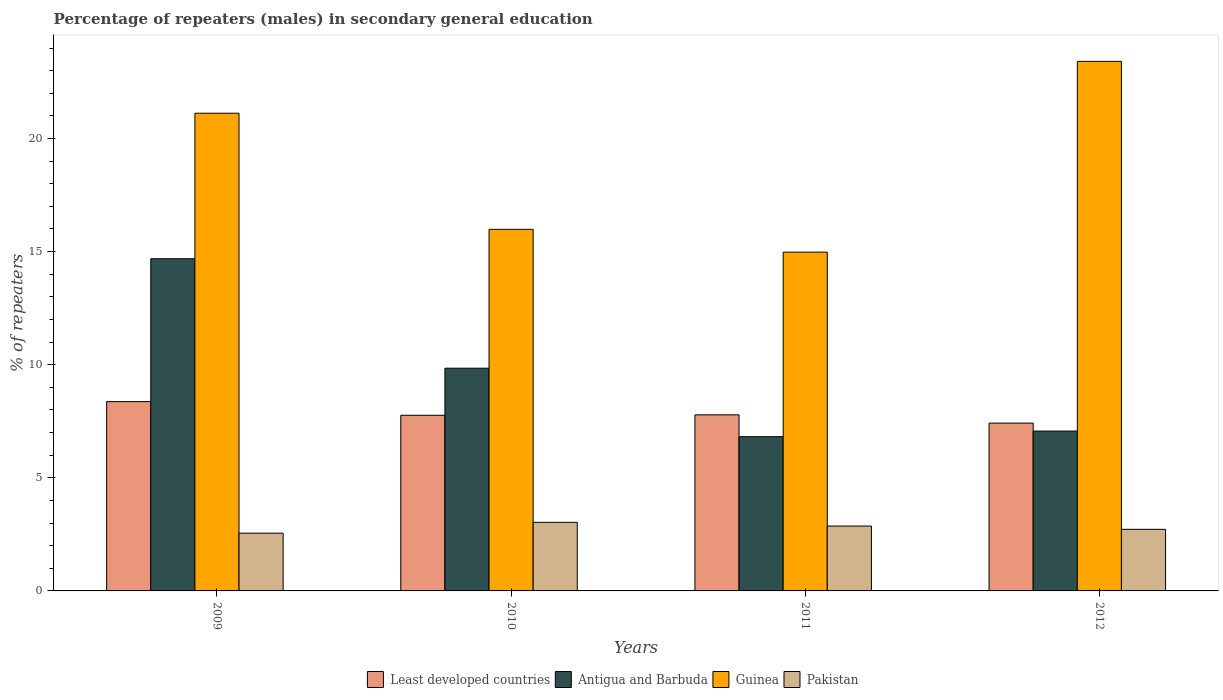How many different coloured bars are there?
Offer a terse response. 4. Are the number of bars on each tick of the X-axis equal?
Keep it short and to the point. Yes. How many bars are there on the 1st tick from the right?
Offer a terse response. 4. What is the label of the 4th group of bars from the left?
Ensure brevity in your answer.  2012. What is the percentage of male repeaters in Guinea in 2009?
Your answer should be compact. 21.12. Across all years, what is the maximum percentage of male repeaters in Guinea?
Give a very brief answer. 23.41. Across all years, what is the minimum percentage of male repeaters in Antigua and Barbuda?
Provide a succinct answer. 6.82. In which year was the percentage of male repeaters in Pakistan maximum?
Offer a very short reply. 2010. In which year was the percentage of male repeaters in Guinea minimum?
Ensure brevity in your answer.  2011. What is the total percentage of male repeaters in Pakistan in the graph?
Offer a terse response. 11.18. What is the difference between the percentage of male repeaters in Least developed countries in 2010 and that in 2011?
Ensure brevity in your answer.  -0.02. What is the difference between the percentage of male repeaters in Least developed countries in 2009 and the percentage of male repeaters in Antigua and Barbuda in 2012?
Offer a very short reply. 1.3. What is the average percentage of male repeaters in Guinea per year?
Your answer should be compact. 18.87. In the year 2009, what is the difference between the percentage of male repeaters in Guinea and percentage of male repeaters in Least developed countries?
Your answer should be compact. 12.75. In how many years, is the percentage of male repeaters in Least developed countries greater than 17 %?
Make the answer very short. 0. What is the ratio of the percentage of male repeaters in Pakistan in 2010 to that in 2011?
Keep it short and to the point. 1.06. Is the percentage of male repeaters in Antigua and Barbuda in 2010 less than that in 2012?
Provide a succinct answer. No. Is the difference between the percentage of male repeaters in Guinea in 2009 and 2011 greater than the difference between the percentage of male repeaters in Least developed countries in 2009 and 2011?
Provide a succinct answer. Yes. What is the difference between the highest and the second highest percentage of male repeaters in Guinea?
Ensure brevity in your answer.  2.29. What is the difference between the highest and the lowest percentage of male repeaters in Least developed countries?
Your answer should be compact. 0.95. Is the sum of the percentage of male repeaters in Guinea in 2010 and 2012 greater than the maximum percentage of male repeaters in Antigua and Barbuda across all years?
Provide a short and direct response. Yes. Is it the case that in every year, the sum of the percentage of male repeaters in Pakistan and percentage of male repeaters in Least developed countries is greater than the sum of percentage of male repeaters in Antigua and Barbuda and percentage of male repeaters in Guinea?
Offer a very short reply. No. What does the 1st bar from the left in 2010 represents?
Keep it short and to the point. Least developed countries. What does the 2nd bar from the right in 2011 represents?
Make the answer very short. Guinea. How many bars are there?
Provide a succinct answer. 16. Are all the bars in the graph horizontal?
Your answer should be compact. No. How many years are there in the graph?
Your answer should be compact. 4. Where does the legend appear in the graph?
Keep it short and to the point. Bottom center. How many legend labels are there?
Provide a succinct answer. 4. What is the title of the graph?
Your answer should be compact. Percentage of repeaters (males) in secondary general education. What is the label or title of the X-axis?
Offer a terse response. Years. What is the label or title of the Y-axis?
Give a very brief answer. % of repeaters. What is the % of repeaters of Least developed countries in 2009?
Your response must be concise. 8.37. What is the % of repeaters in Antigua and Barbuda in 2009?
Provide a short and direct response. 14.69. What is the % of repeaters of Guinea in 2009?
Provide a short and direct response. 21.12. What is the % of repeaters in Pakistan in 2009?
Offer a terse response. 2.55. What is the % of repeaters of Least developed countries in 2010?
Offer a very short reply. 7.76. What is the % of repeaters in Antigua and Barbuda in 2010?
Your answer should be very brief. 9.85. What is the % of repeaters of Guinea in 2010?
Provide a short and direct response. 15.98. What is the % of repeaters in Pakistan in 2010?
Provide a succinct answer. 3.03. What is the % of repeaters of Least developed countries in 2011?
Offer a very short reply. 7.78. What is the % of repeaters of Antigua and Barbuda in 2011?
Your response must be concise. 6.82. What is the % of repeaters in Guinea in 2011?
Provide a short and direct response. 14.98. What is the % of repeaters of Pakistan in 2011?
Provide a short and direct response. 2.87. What is the % of repeaters of Least developed countries in 2012?
Your answer should be very brief. 7.42. What is the % of repeaters in Antigua and Barbuda in 2012?
Offer a terse response. 7.07. What is the % of repeaters of Guinea in 2012?
Offer a terse response. 23.41. What is the % of repeaters of Pakistan in 2012?
Offer a terse response. 2.72. Across all years, what is the maximum % of repeaters in Least developed countries?
Your answer should be compact. 8.37. Across all years, what is the maximum % of repeaters in Antigua and Barbuda?
Make the answer very short. 14.69. Across all years, what is the maximum % of repeaters of Guinea?
Your answer should be very brief. 23.41. Across all years, what is the maximum % of repeaters in Pakistan?
Provide a short and direct response. 3.03. Across all years, what is the minimum % of repeaters of Least developed countries?
Give a very brief answer. 7.42. Across all years, what is the minimum % of repeaters of Antigua and Barbuda?
Keep it short and to the point. 6.82. Across all years, what is the minimum % of repeaters of Guinea?
Ensure brevity in your answer.  14.98. Across all years, what is the minimum % of repeaters in Pakistan?
Provide a short and direct response. 2.55. What is the total % of repeaters in Least developed countries in the graph?
Ensure brevity in your answer.  31.34. What is the total % of repeaters in Antigua and Barbuda in the graph?
Give a very brief answer. 38.42. What is the total % of repeaters in Guinea in the graph?
Provide a short and direct response. 75.49. What is the total % of repeaters of Pakistan in the graph?
Provide a short and direct response. 11.18. What is the difference between the % of repeaters in Least developed countries in 2009 and that in 2010?
Your answer should be very brief. 0.6. What is the difference between the % of repeaters in Antigua and Barbuda in 2009 and that in 2010?
Provide a short and direct response. 4.84. What is the difference between the % of repeaters in Guinea in 2009 and that in 2010?
Offer a very short reply. 5.13. What is the difference between the % of repeaters of Pakistan in 2009 and that in 2010?
Your answer should be very brief. -0.48. What is the difference between the % of repeaters in Least developed countries in 2009 and that in 2011?
Keep it short and to the point. 0.58. What is the difference between the % of repeaters of Antigua and Barbuda in 2009 and that in 2011?
Make the answer very short. 7.87. What is the difference between the % of repeaters of Guinea in 2009 and that in 2011?
Make the answer very short. 6.14. What is the difference between the % of repeaters in Pakistan in 2009 and that in 2011?
Your response must be concise. -0.31. What is the difference between the % of repeaters of Least developed countries in 2009 and that in 2012?
Provide a succinct answer. 0.95. What is the difference between the % of repeaters in Antigua and Barbuda in 2009 and that in 2012?
Give a very brief answer. 7.62. What is the difference between the % of repeaters in Guinea in 2009 and that in 2012?
Offer a terse response. -2.29. What is the difference between the % of repeaters in Pakistan in 2009 and that in 2012?
Give a very brief answer. -0.17. What is the difference between the % of repeaters in Least developed countries in 2010 and that in 2011?
Ensure brevity in your answer.  -0.02. What is the difference between the % of repeaters of Antigua and Barbuda in 2010 and that in 2011?
Your answer should be very brief. 3.03. What is the difference between the % of repeaters in Guinea in 2010 and that in 2011?
Provide a succinct answer. 1.01. What is the difference between the % of repeaters of Pakistan in 2010 and that in 2011?
Provide a succinct answer. 0.16. What is the difference between the % of repeaters in Least developed countries in 2010 and that in 2012?
Ensure brevity in your answer.  0.35. What is the difference between the % of repeaters in Antigua and Barbuda in 2010 and that in 2012?
Offer a terse response. 2.78. What is the difference between the % of repeaters in Guinea in 2010 and that in 2012?
Your answer should be compact. -7.43. What is the difference between the % of repeaters in Pakistan in 2010 and that in 2012?
Offer a terse response. 0.31. What is the difference between the % of repeaters in Least developed countries in 2011 and that in 2012?
Ensure brevity in your answer.  0.37. What is the difference between the % of repeaters of Antigua and Barbuda in 2011 and that in 2012?
Give a very brief answer. -0.25. What is the difference between the % of repeaters in Guinea in 2011 and that in 2012?
Your answer should be compact. -8.43. What is the difference between the % of repeaters of Pakistan in 2011 and that in 2012?
Give a very brief answer. 0.15. What is the difference between the % of repeaters of Least developed countries in 2009 and the % of repeaters of Antigua and Barbuda in 2010?
Keep it short and to the point. -1.48. What is the difference between the % of repeaters in Least developed countries in 2009 and the % of repeaters in Guinea in 2010?
Give a very brief answer. -7.62. What is the difference between the % of repeaters in Least developed countries in 2009 and the % of repeaters in Pakistan in 2010?
Provide a short and direct response. 5.34. What is the difference between the % of repeaters in Antigua and Barbuda in 2009 and the % of repeaters in Guinea in 2010?
Offer a terse response. -1.3. What is the difference between the % of repeaters in Antigua and Barbuda in 2009 and the % of repeaters in Pakistan in 2010?
Offer a terse response. 11.65. What is the difference between the % of repeaters of Guinea in 2009 and the % of repeaters of Pakistan in 2010?
Offer a very short reply. 18.09. What is the difference between the % of repeaters in Least developed countries in 2009 and the % of repeaters in Antigua and Barbuda in 2011?
Keep it short and to the point. 1.55. What is the difference between the % of repeaters in Least developed countries in 2009 and the % of repeaters in Guinea in 2011?
Provide a short and direct response. -6.61. What is the difference between the % of repeaters of Least developed countries in 2009 and the % of repeaters of Pakistan in 2011?
Your answer should be compact. 5.5. What is the difference between the % of repeaters in Antigua and Barbuda in 2009 and the % of repeaters in Guinea in 2011?
Ensure brevity in your answer.  -0.29. What is the difference between the % of repeaters of Antigua and Barbuda in 2009 and the % of repeaters of Pakistan in 2011?
Offer a very short reply. 11.82. What is the difference between the % of repeaters of Guinea in 2009 and the % of repeaters of Pakistan in 2011?
Offer a terse response. 18.25. What is the difference between the % of repeaters in Least developed countries in 2009 and the % of repeaters in Antigua and Barbuda in 2012?
Offer a terse response. 1.3. What is the difference between the % of repeaters in Least developed countries in 2009 and the % of repeaters in Guinea in 2012?
Give a very brief answer. -15.04. What is the difference between the % of repeaters in Least developed countries in 2009 and the % of repeaters in Pakistan in 2012?
Give a very brief answer. 5.65. What is the difference between the % of repeaters in Antigua and Barbuda in 2009 and the % of repeaters in Guinea in 2012?
Offer a very short reply. -8.72. What is the difference between the % of repeaters of Antigua and Barbuda in 2009 and the % of repeaters of Pakistan in 2012?
Provide a short and direct response. 11.96. What is the difference between the % of repeaters in Guinea in 2009 and the % of repeaters in Pakistan in 2012?
Your response must be concise. 18.4. What is the difference between the % of repeaters in Least developed countries in 2010 and the % of repeaters in Antigua and Barbuda in 2011?
Your answer should be very brief. 0.95. What is the difference between the % of repeaters in Least developed countries in 2010 and the % of repeaters in Guinea in 2011?
Provide a succinct answer. -7.21. What is the difference between the % of repeaters of Least developed countries in 2010 and the % of repeaters of Pakistan in 2011?
Your response must be concise. 4.9. What is the difference between the % of repeaters of Antigua and Barbuda in 2010 and the % of repeaters of Guinea in 2011?
Offer a very short reply. -5.13. What is the difference between the % of repeaters in Antigua and Barbuda in 2010 and the % of repeaters in Pakistan in 2011?
Make the answer very short. 6.98. What is the difference between the % of repeaters of Guinea in 2010 and the % of repeaters of Pakistan in 2011?
Your answer should be very brief. 13.12. What is the difference between the % of repeaters in Least developed countries in 2010 and the % of repeaters in Antigua and Barbuda in 2012?
Make the answer very short. 0.7. What is the difference between the % of repeaters of Least developed countries in 2010 and the % of repeaters of Guinea in 2012?
Make the answer very short. -15.65. What is the difference between the % of repeaters in Least developed countries in 2010 and the % of repeaters in Pakistan in 2012?
Make the answer very short. 5.04. What is the difference between the % of repeaters of Antigua and Barbuda in 2010 and the % of repeaters of Guinea in 2012?
Your response must be concise. -13.57. What is the difference between the % of repeaters in Antigua and Barbuda in 2010 and the % of repeaters in Pakistan in 2012?
Your response must be concise. 7.12. What is the difference between the % of repeaters in Guinea in 2010 and the % of repeaters in Pakistan in 2012?
Your answer should be compact. 13.26. What is the difference between the % of repeaters in Least developed countries in 2011 and the % of repeaters in Antigua and Barbuda in 2012?
Provide a short and direct response. 0.72. What is the difference between the % of repeaters of Least developed countries in 2011 and the % of repeaters of Guinea in 2012?
Offer a very short reply. -15.63. What is the difference between the % of repeaters in Least developed countries in 2011 and the % of repeaters in Pakistan in 2012?
Provide a short and direct response. 5.06. What is the difference between the % of repeaters of Antigua and Barbuda in 2011 and the % of repeaters of Guinea in 2012?
Provide a short and direct response. -16.59. What is the difference between the % of repeaters of Antigua and Barbuda in 2011 and the % of repeaters of Pakistan in 2012?
Your answer should be very brief. 4.1. What is the difference between the % of repeaters in Guinea in 2011 and the % of repeaters in Pakistan in 2012?
Give a very brief answer. 12.26. What is the average % of repeaters in Least developed countries per year?
Give a very brief answer. 7.83. What is the average % of repeaters of Antigua and Barbuda per year?
Your answer should be compact. 9.6. What is the average % of repeaters in Guinea per year?
Your answer should be very brief. 18.87. What is the average % of repeaters of Pakistan per year?
Keep it short and to the point. 2.79. In the year 2009, what is the difference between the % of repeaters of Least developed countries and % of repeaters of Antigua and Barbuda?
Provide a succinct answer. -6.32. In the year 2009, what is the difference between the % of repeaters of Least developed countries and % of repeaters of Guinea?
Your answer should be compact. -12.75. In the year 2009, what is the difference between the % of repeaters in Least developed countries and % of repeaters in Pakistan?
Your response must be concise. 5.81. In the year 2009, what is the difference between the % of repeaters in Antigua and Barbuda and % of repeaters in Guinea?
Make the answer very short. -6.43. In the year 2009, what is the difference between the % of repeaters of Antigua and Barbuda and % of repeaters of Pakistan?
Offer a terse response. 12.13. In the year 2009, what is the difference between the % of repeaters in Guinea and % of repeaters in Pakistan?
Your answer should be very brief. 18.56. In the year 2010, what is the difference between the % of repeaters of Least developed countries and % of repeaters of Antigua and Barbuda?
Your answer should be compact. -2.08. In the year 2010, what is the difference between the % of repeaters of Least developed countries and % of repeaters of Guinea?
Your response must be concise. -8.22. In the year 2010, what is the difference between the % of repeaters in Least developed countries and % of repeaters in Pakistan?
Your answer should be very brief. 4.73. In the year 2010, what is the difference between the % of repeaters of Antigua and Barbuda and % of repeaters of Guinea?
Give a very brief answer. -6.14. In the year 2010, what is the difference between the % of repeaters of Antigua and Barbuda and % of repeaters of Pakistan?
Make the answer very short. 6.81. In the year 2010, what is the difference between the % of repeaters in Guinea and % of repeaters in Pakistan?
Your response must be concise. 12.95. In the year 2011, what is the difference between the % of repeaters of Least developed countries and % of repeaters of Antigua and Barbuda?
Make the answer very short. 0.97. In the year 2011, what is the difference between the % of repeaters in Least developed countries and % of repeaters in Guinea?
Provide a short and direct response. -7.19. In the year 2011, what is the difference between the % of repeaters in Least developed countries and % of repeaters in Pakistan?
Make the answer very short. 4.92. In the year 2011, what is the difference between the % of repeaters in Antigua and Barbuda and % of repeaters in Guinea?
Provide a short and direct response. -8.16. In the year 2011, what is the difference between the % of repeaters of Antigua and Barbuda and % of repeaters of Pakistan?
Give a very brief answer. 3.95. In the year 2011, what is the difference between the % of repeaters of Guinea and % of repeaters of Pakistan?
Your answer should be compact. 12.11. In the year 2012, what is the difference between the % of repeaters of Least developed countries and % of repeaters of Antigua and Barbuda?
Make the answer very short. 0.35. In the year 2012, what is the difference between the % of repeaters in Least developed countries and % of repeaters in Guinea?
Offer a terse response. -15.99. In the year 2012, what is the difference between the % of repeaters of Least developed countries and % of repeaters of Pakistan?
Provide a succinct answer. 4.7. In the year 2012, what is the difference between the % of repeaters in Antigua and Barbuda and % of repeaters in Guinea?
Make the answer very short. -16.34. In the year 2012, what is the difference between the % of repeaters of Antigua and Barbuda and % of repeaters of Pakistan?
Your answer should be compact. 4.34. In the year 2012, what is the difference between the % of repeaters of Guinea and % of repeaters of Pakistan?
Your response must be concise. 20.69. What is the ratio of the % of repeaters of Least developed countries in 2009 to that in 2010?
Give a very brief answer. 1.08. What is the ratio of the % of repeaters in Antigua and Barbuda in 2009 to that in 2010?
Offer a terse response. 1.49. What is the ratio of the % of repeaters of Guinea in 2009 to that in 2010?
Your response must be concise. 1.32. What is the ratio of the % of repeaters in Pakistan in 2009 to that in 2010?
Your response must be concise. 0.84. What is the ratio of the % of repeaters in Least developed countries in 2009 to that in 2011?
Give a very brief answer. 1.07. What is the ratio of the % of repeaters of Antigua and Barbuda in 2009 to that in 2011?
Your answer should be very brief. 2.15. What is the ratio of the % of repeaters of Guinea in 2009 to that in 2011?
Your response must be concise. 1.41. What is the ratio of the % of repeaters of Pakistan in 2009 to that in 2011?
Offer a very short reply. 0.89. What is the ratio of the % of repeaters in Least developed countries in 2009 to that in 2012?
Provide a succinct answer. 1.13. What is the ratio of the % of repeaters of Antigua and Barbuda in 2009 to that in 2012?
Give a very brief answer. 2.08. What is the ratio of the % of repeaters in Guinea in 2009 to that in 2012?
Give a very brief answer. 0.9. What is the ratio of the % of repeaters in Pakistan in 2009 to that in 2012?
Make the answer very short. 0.94. What is the ratio of the % of repeaters in Least developed countries in 2010 to that in 2011?
Ensure brevity in your answer.  1. What is the ratio of the % of repeaters in Antigua and Barbuda in 2010 to that in 2011?
Make the answer very short. 1.44. What is the ratio of the % of repeaters in Guinea in 2010 to that in 2011?
Your answer should be very brief. 1.07. What is the ratio of the % of repeaters in Pakistan in 2010 to that in 2011?
Your answer should be very brief. 1.06. What is the ratio of the % of repeaters in Least developed countries in 2010 to that in 2012?
Your response must be concise. 1.05. What is the ratio of the % of repeaters in Antigua and Barbuda in 2010 to that in 2012?
Your answer should be compact. 1.39. What is the ratio of the % of repeaters of Guinea in 2010 to that in 2012?
Your answer should be very brief. 0.68. What is the ratio of the % of repeaters of Pakistan in 2010 to that in 2012?
Your answer should be very brief. 1.11. What is the ratio of the % of repeaters in Least developed countries in 2011 to that in 2012?
Your response must be concise. 1.05. What is the ratio of the % of repeaters of Antigua and Barbuda in 2011 to that in 2012?
Give a very brief answer. 0.96. What is the ratio of the % of repeaters of Guinea in 2011 to that in 2012?
Your answer should be compact. 0.64. What is the ratio of the % of repeaters of Pakistan in 2011 to that in 2012?
Your answer should be very brief. 1.05. What is the difference between the highest and the second highest % of repeaters of Least developed countries?
Offer a terse response. 0.58. What is the difference between the highest and the second highest % of repeaters of Antigua and Barbuda?
Offer a terse response. 4.84. What is the difference between the highest and the second highest % of repeaters of Guinea?
Keep it short and to the point. 2.29. What is the difference between the highest and the second highest % of repeaters in Pakistan?
Offer a terse response. 0.16. What is the difference between the highest and the lowest % of repeaters of Least developed countries?
Offer a very short reply. 0.95. What is the difference between the highest and the lowest % of repeaters of Antigua and Barbuda?
Your response must be concise. 7.87. What is the difference between the highest and the lowest % of repeaters of Guinea?
Provide a short and direct response. 8.43. What is the difference between the highest and the lowest % of repeaters of Pakistan?
Offer a very short reply. 0.48. 